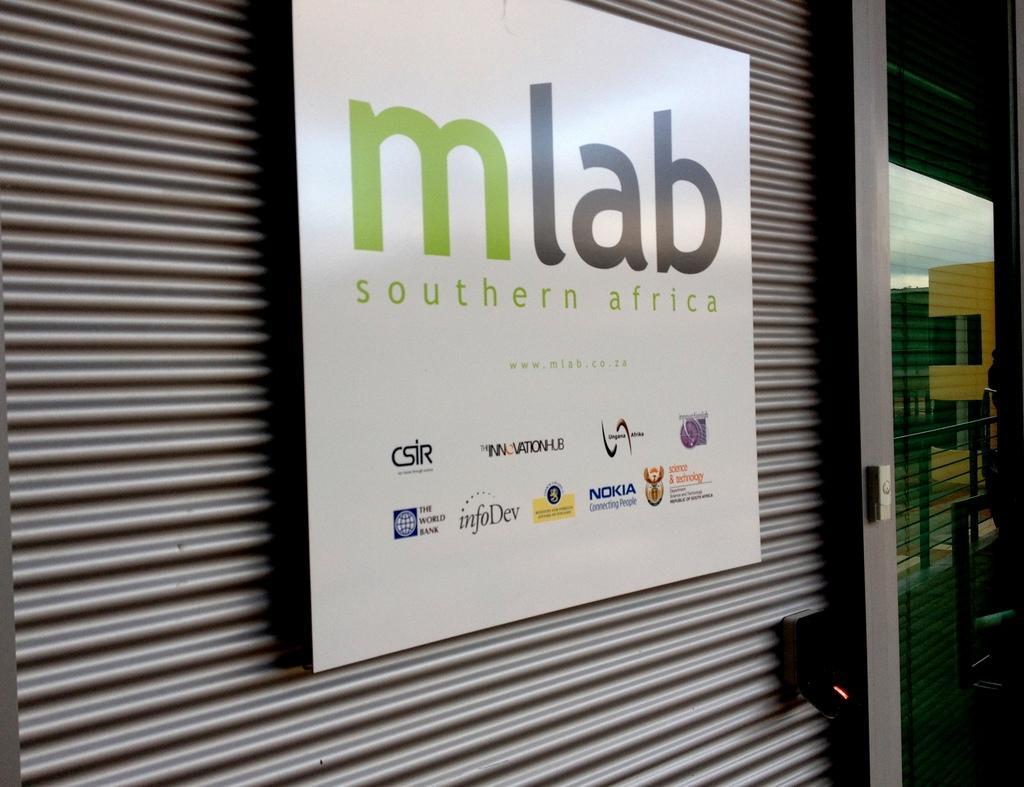Please provide a concise description of this image. In this image there is a advertising banner on the shutter, beside that there is a glass with a reflection of buildings on it. 